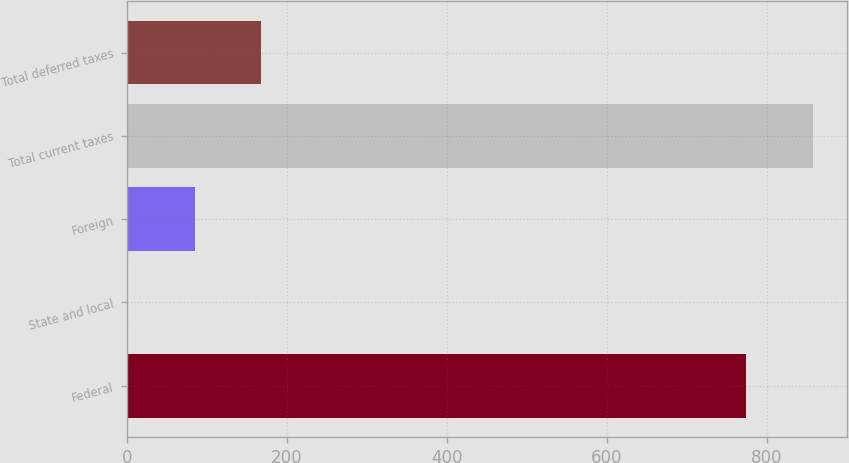<chart> <loc_0><loc_0><loc_500><loc_500><bar_chart><fcel>Federal<fcel>State and local<fcel>Foreign<fcel>Total current taxes<fcel>Total deferred taxes<nl><fcel>774.4<fcel>1<fcel>84.41<fcel>857.81<fcel>167.82<nl></chart> 